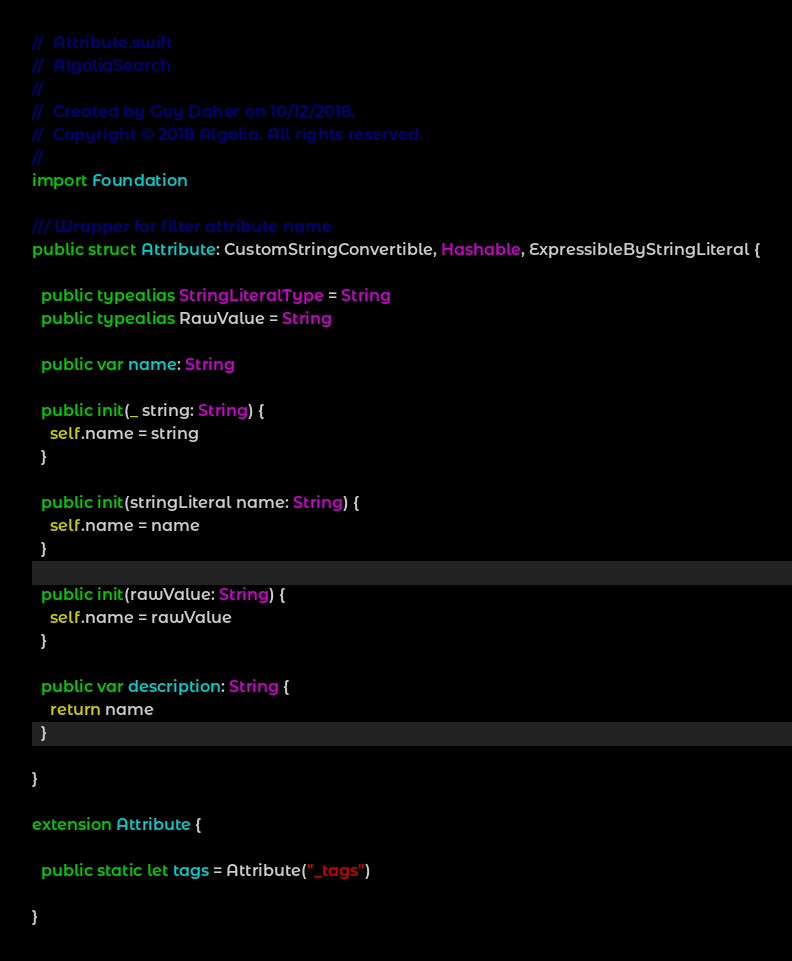<code> <loc_0><loc_0><loc_500><loc_500><_Swift_>//  Attribute.swift
//  AlgoliaSearch
//
//  Created by Guy Daher on 10/12/2018.
//  Copyright © 2018 Algolia. All rights reserved.
//
import Foundation

/// Wrapper for filter attribute name
public struct Attribute: CustomStringConvertible, Hashable, ExpressibleByStringLiteral {
  
  public typealias StringLiteralType = String
  public typealias RawValue = String
  
  public var name: String
  
  public init(_ string: String) {
    self.name = string
  }
  
  public init(stringLiteral name: String) {
    self.name = name
  }
  
  public init(rawValue: String) {
    self.name = rawValue
  }
  
  public var description: String {
    return name
  }
  
}

extension Attribute {
  
  public static let tags = Attribute("_tags")
  
}
</code> 